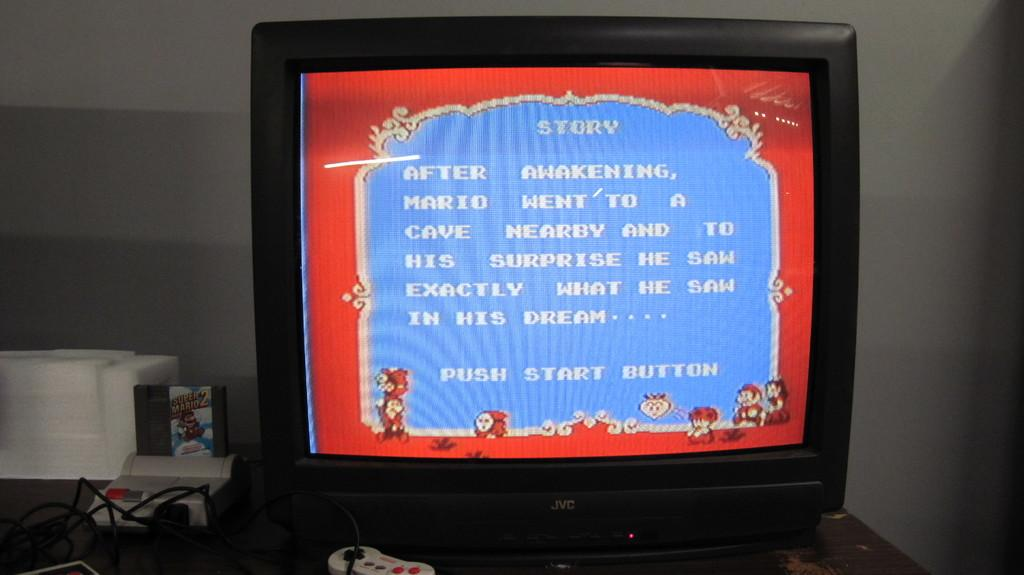<image>
Provide a brief description of the given image. An old fashioned video game on the screen, starts with Story. 